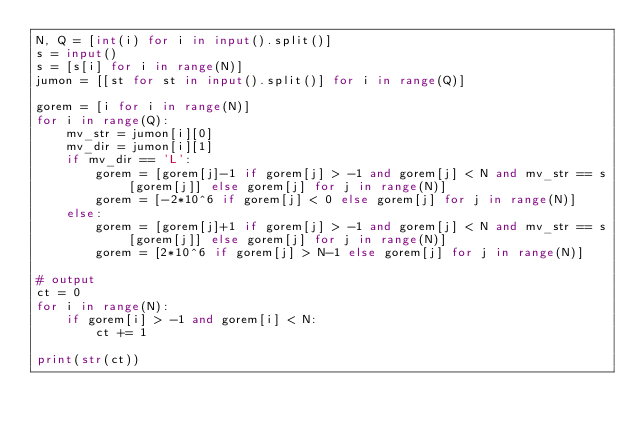Convert code to text. <code><loc_0><loc_0><loc_500><loc_500><_Python_>N, Q = [int(i) for i in input().split()]
s = input()
s = [s[i] for i in range(N)]
jumon = [[st for st in input().split()] for i in range(Q)]

gorem = [i for i in range(N)]
for i in range(Q):
    mv_str = jumon[i][0]
    mv_dir = jumon[i][1]
    if mv_dir == 'L':
        gorem = [gorem[j]-1 if gorem[j] > -1 and gorem[j] < N and mv_str == s[gorem[j]] else gorem[j] for j in range(N)]
        gorem = [-2*10^6 if gorem[j] < 0 else gorem[j] for j in range(N)]
    else:
        gorem = [gorem[j]+1 if gorem[j] > -1 and gorem[j] < N and mv_str == s[gorem[j]] else gorem[j] for j in range(N)]
        gorem = [2*10^6 if gorem[j] > N-1 else gorem[j] for j in range(N)]

# output
ct = 0
for i in range(N):
    if gorem[i] > -1 and gorem[i] < N:
        ct += 1

print(str(ct))
</code> 